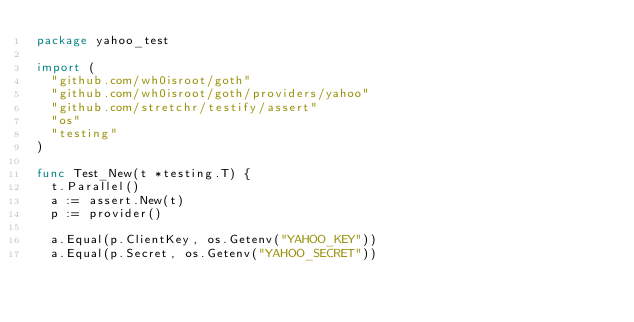<code> <loc_0><loc_0><loc_500><loc_500><_Go_>package yahoo_test

import (
	"github.com/wh0isroot/goth"
	"github.com/wh0isroot/goth/providers/yahoo"
	"github.com/stretchr/testify/assert"
	"os"
	"testing"
)

func Test_New(t *testing.T) {
	t.Parallel()
	a := assert.New(t)
	p := provider()

	a.Equal(p.ClientKey, os.Getenv("YAHOO_KEY"))
	a.Equal(p.Secret, os.Getenv("YAHOO_SECRET"))</code> 